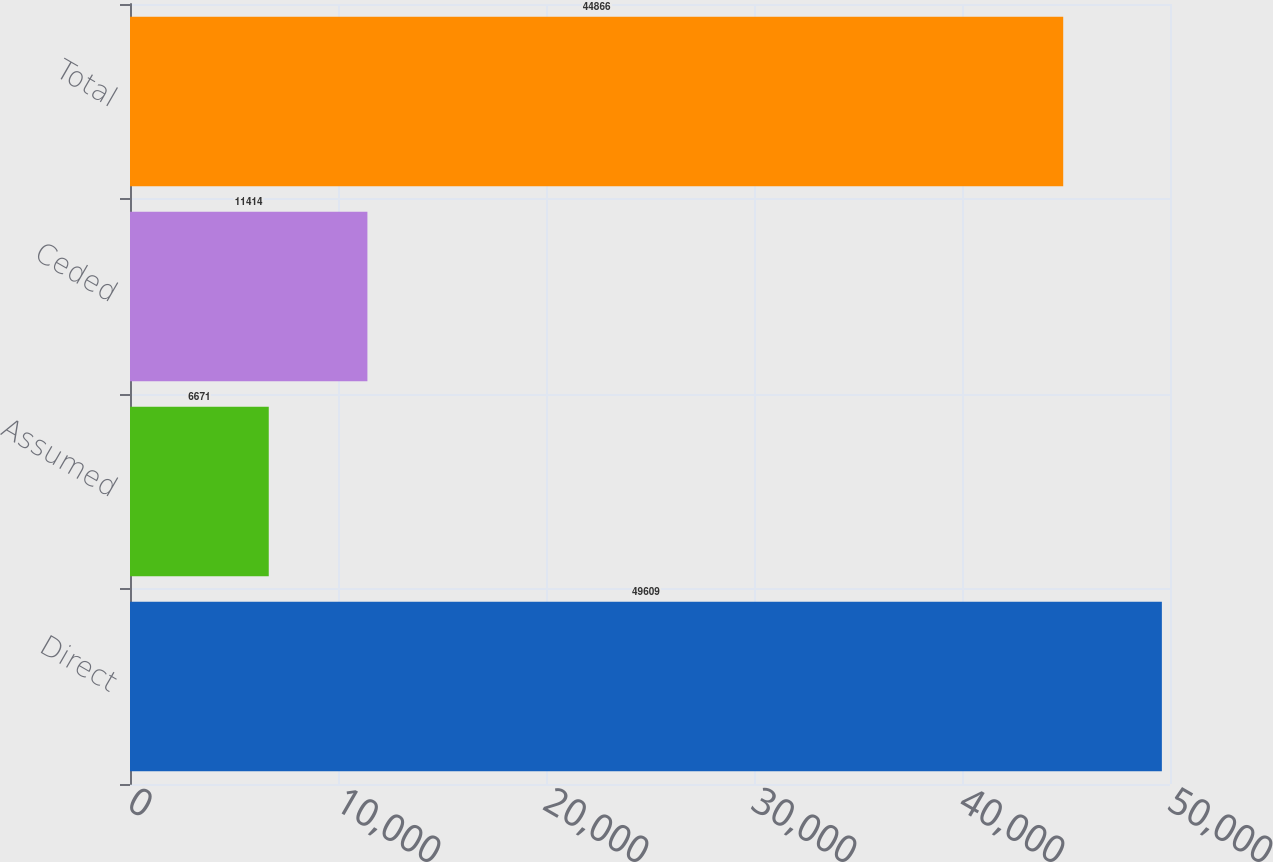Convert chart. <chart><loc_0><loc_0><loc_500><loc_500><bar_chart><fcel>Direct<fcel>Assumed<fcel>Ceded<fcel>Total<nl><fcel>49609<fcel>6671<fcel>11414<fcel>44866<nl></chart> 